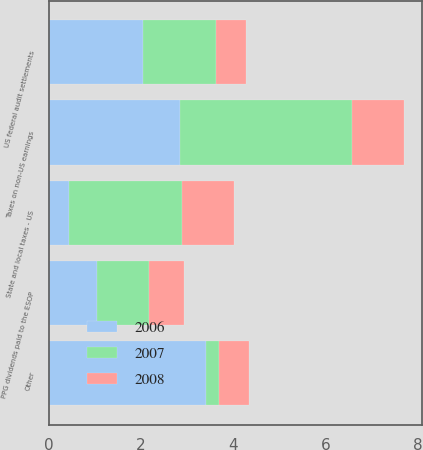Convert chart to OTSL. <chart><loc_0><loc_0><loc_500><loc_500><stacked_bar_chart><ecel><fcel>State and local taxes - US<fcel>Taxes on non-US earnings<fcel>PPG dividends paid to the ESOP<fcel>US federal audit settlements<fcel>Other<nl><fcel>2007<fcel>2.47<fcel>3.75<fcel>1.13<fcel>1.59<fcel>0.28<nl><fcel>2008<fcel>1.12<fcel>1.125<fcel>0.76<fcel>0.64<fcel>0.65<nl><fcel>2006<fcel>0.43<fcel>2.84<fcel>1.04<fcel>2.04<fcel>3.41<nl></chart> 